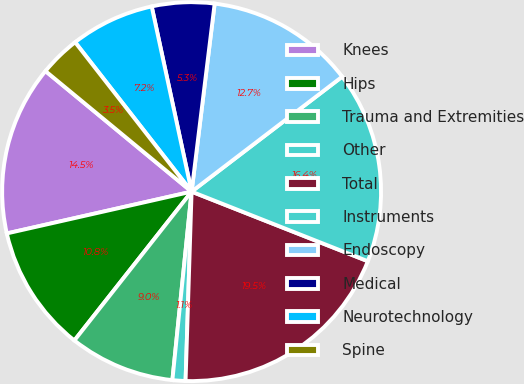Convert chart to OTSL. <chart><loc_0><loc_0><loc_500><loc_500><pie_chart><fcel>Knees<fcel>Hips<fcel>Trauma and Extremities<fcel>Other<fcel>Total<fcel>Instruments<fcel>Endoscopy<fcel>Medical<fcel>Neurotechnology<fcel>Spine<nl><fcel>14.52%<fcel>10.84%<fcel>9.0%<fcel>1.11%<fcel>19.52%<fcel>16.36%<fcel>12.68%<fcel>5.32%<fcel>7.16%<fcel>3.48%<nl></chart> 